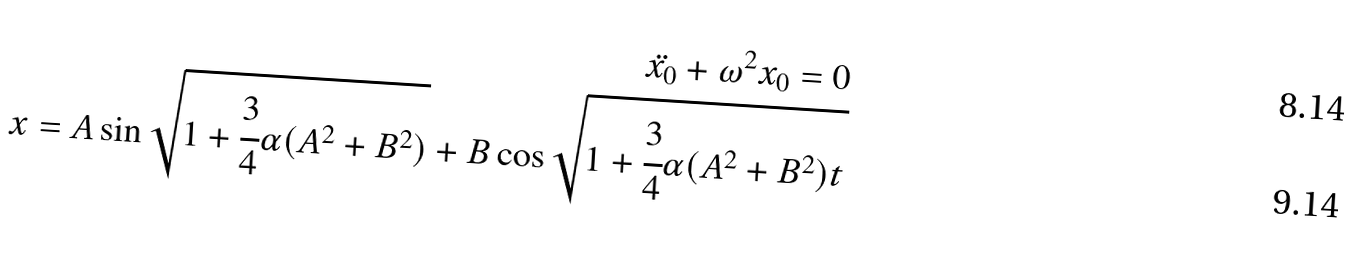Convert formula to latex. <formula><loc_0><loc_0><loc_500><loc_500>\ddot { x _ { 0 } } + { \omega } ^ { 2 } { x _ { 0 } } = 0 \\ x = A \sin \sqrt { 1 + \cfrac { 3 } { 4 } { \alpha } ( A ^ { 2 } + B ^ { 2 } ) } + B \cos \sqrt { 1 + \cfrac { 3 } { 4 } { \alpha } ( A ^ { 2 } + B ^ { 2 } ) t }</formula> 